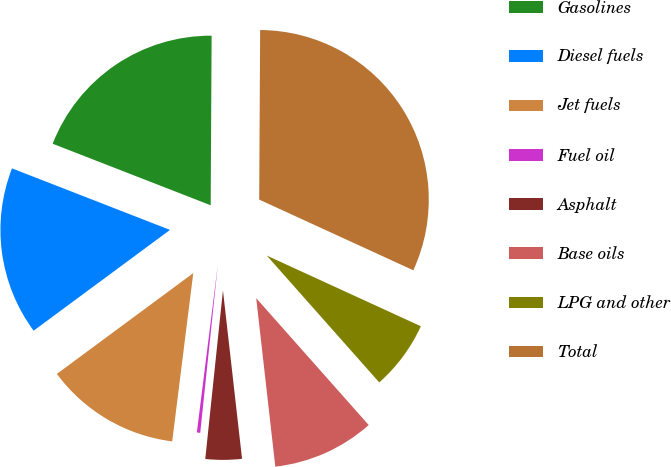Convert chart to OTSL. <chart><loc_0><loc_0><loc_500><loc_500><pie_chart><fcel>Gasolines<fcel>Diesel fuels<fcel>Jet fuels<fcel>Fuel oil<fcel>Asphalt<fcel>Base oils<fcel>LPG and other<fcel>Total<nl><fcel>19.18%<fcel>16.04%<fcel>12.89%<fcel>0.32%<fcel>3.46%<fcel>9.75%<fcel>6.61%<fcel>31.76%<nl></chart> 